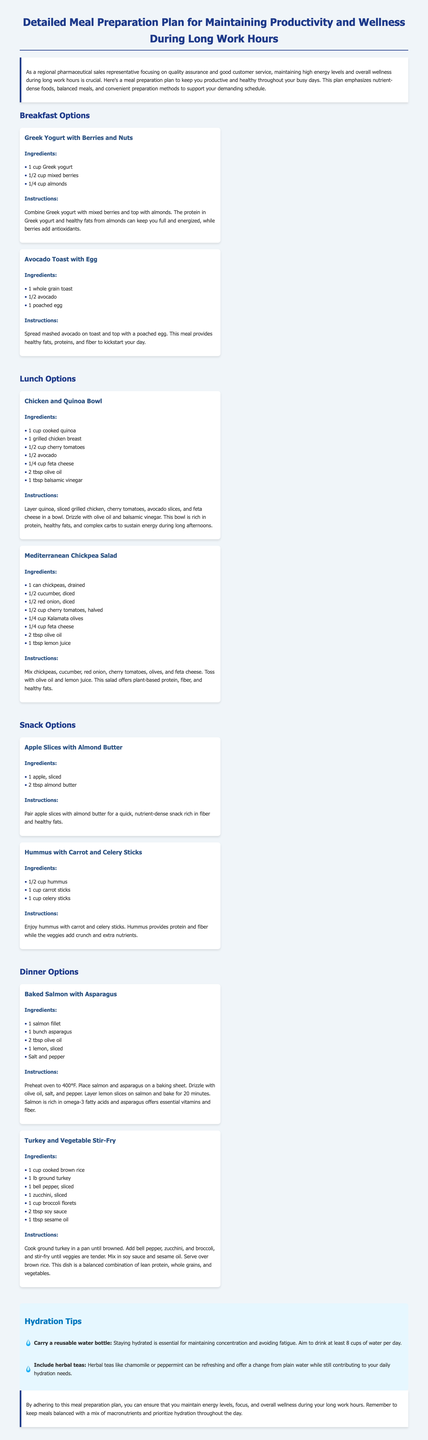What is the title of the document? The title of the document is stated prominently at the top, summarizing the focus of the content.
Answer: Detailed Meal Preparation Plan for Maintaining Productivity and Wellness During Long Work Hours How many breakfast options are provided? The document lists two distinct breakfast options along with their details.
Answer: 2 What is one ingredient in the Chicken and Quinoa Bowl? The Chicken and Quinoa Bowl includes various ingredients listed in the meal section.
Answer: Quinoa How should the Baked Salmon with Asparagus be cooked? The instructions indicate a specific cooking method and temperature for this meal.
Answer: Bake What type of tea is mentioned for hydration? Herbal teas are suggested as a refreshing hydration option in the document.
Answer: Herbal teas What nutrition benefits do berries provide in breakfast? The document highlights the internal benefits of this ingredient related to health.
Answer: Antioxidants Which meal includes ground turkey? By analyzing the meal options provided, the specific meal can be identified.
Answer: Turkey and Vegetable Stir-Fry How are apple slices served in the snack options? This describes how a snack item is presented or combined with another ingredient.
Answer: With almond butter 